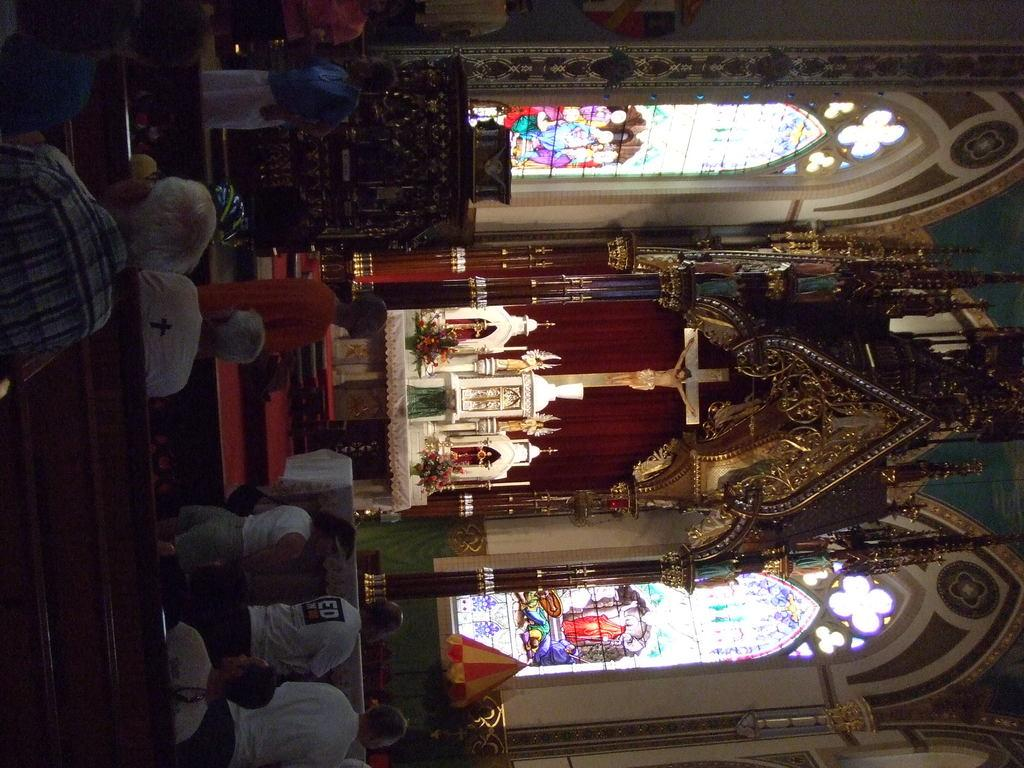What type of building is depicted in the image? The image is an inner view of a church. What religious symbol can be seen in the image? There is a cross with a Jesus sculpture in the image. What are the people in the image doing? There are people sitting on chairs in the image. What type of appliance can be seen in the image? There is no appliance present in the image. How does the waste management system work in the image? There is no mention of waste management in the image, as it is focused on the interior of a church. 